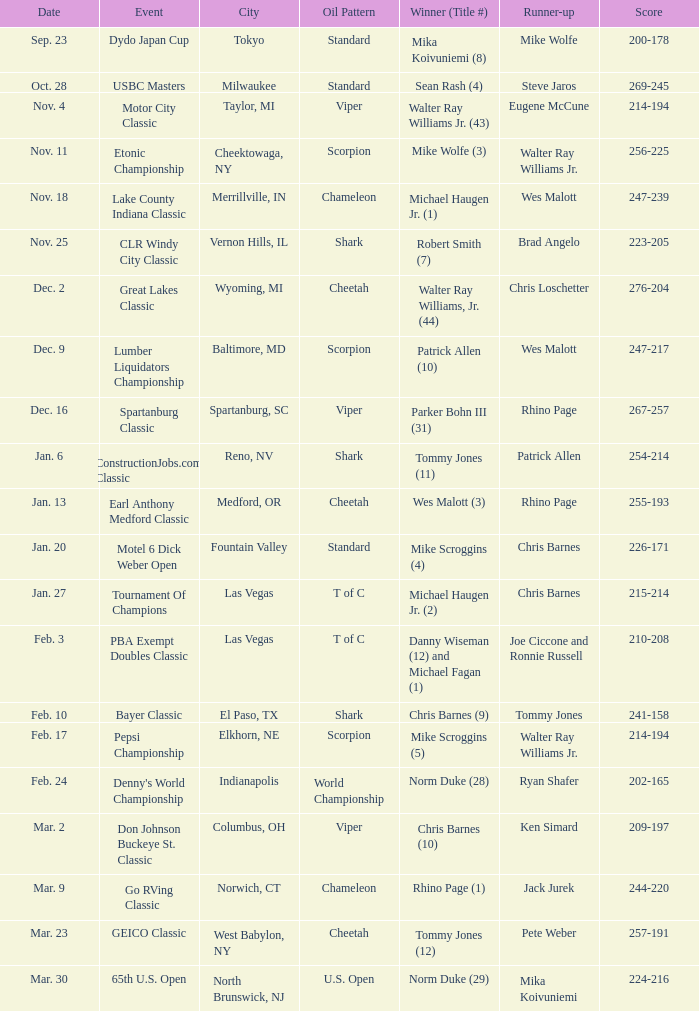Which Score has an Event of constructionjobs.com classic? 254-214. 